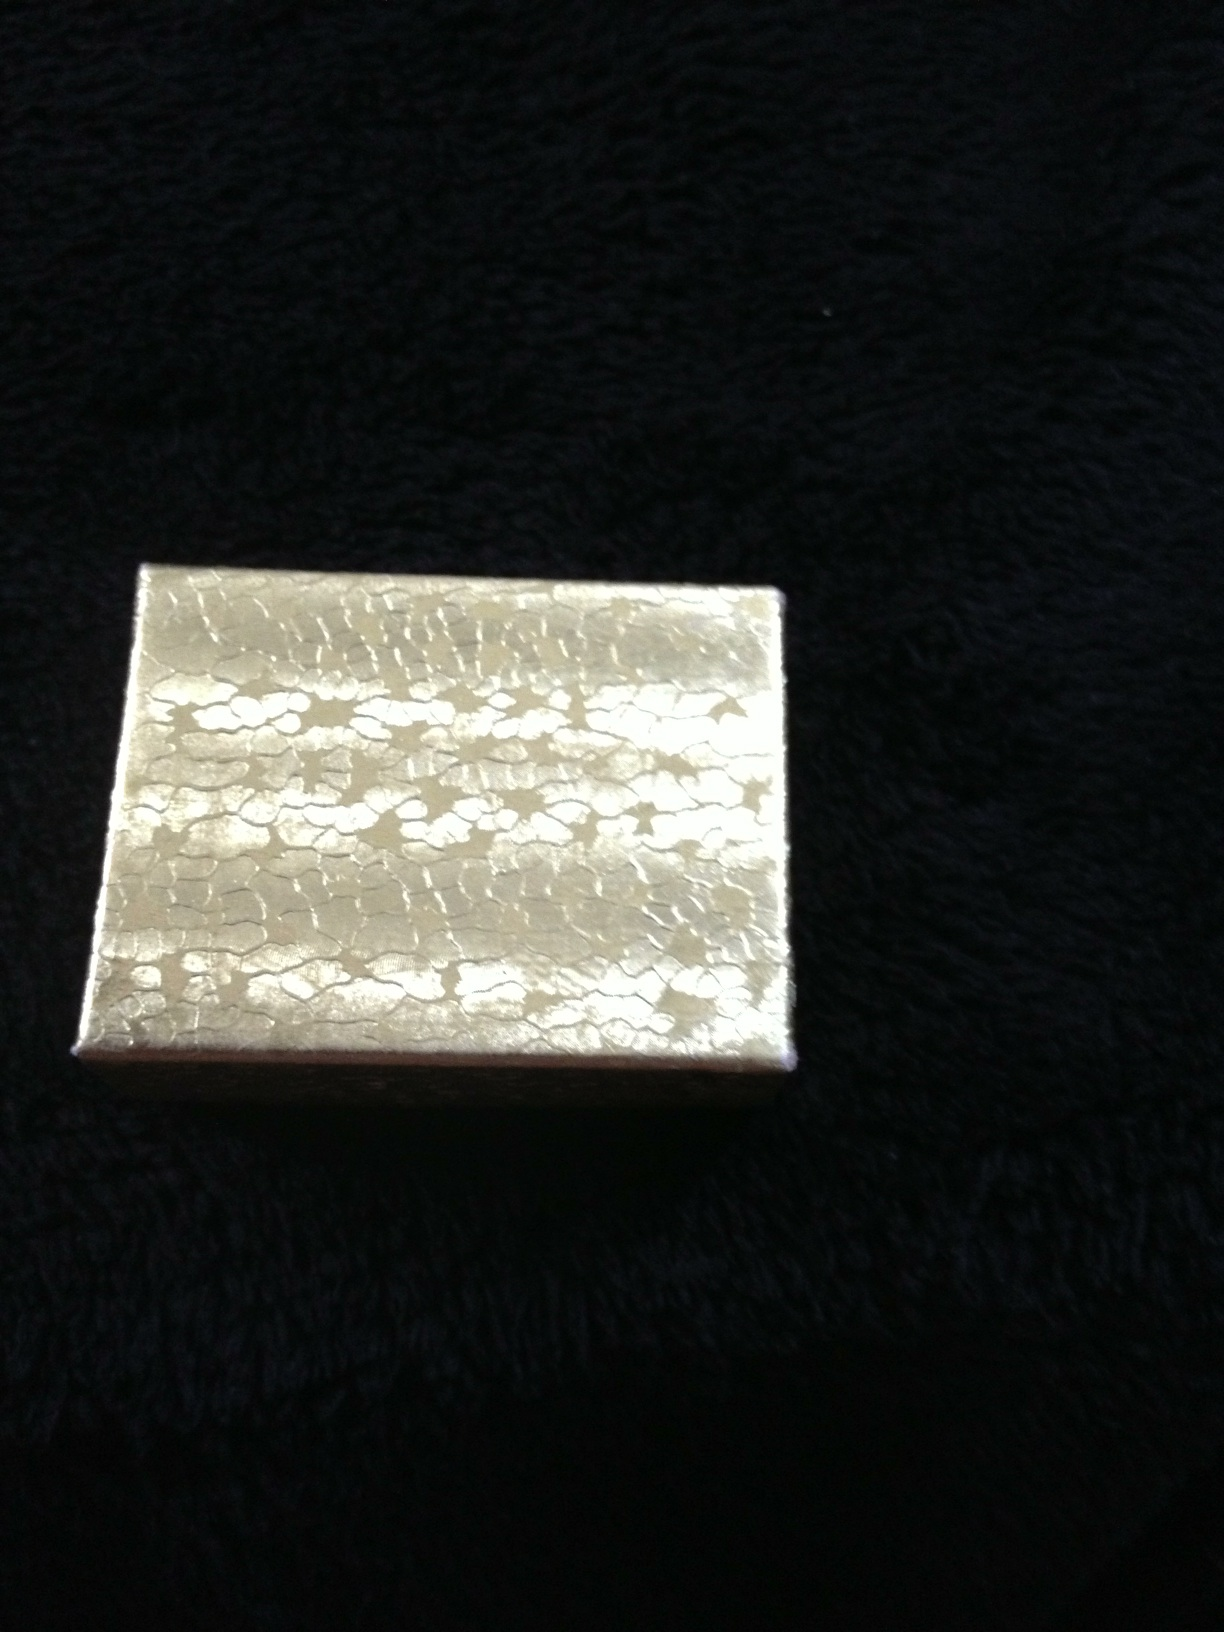Is there any writing on this box? Or what is the writing on this box? No, there is no visible writing on the box. The box appears to have a textured, decorative surface but does not contain any text or labeling. 